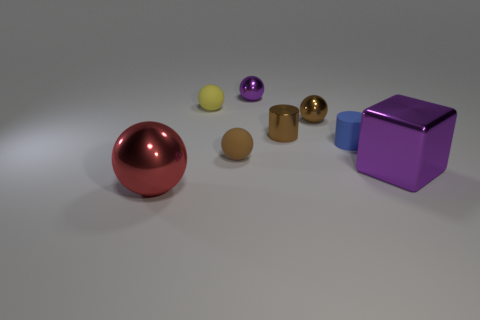There is a rubber object in front of the tiny blue cylinder in front of the tiny matte thing that is on the left side of the brown matte object; what is its color?
Ensure brevity in your answer.  Brown. Are there any other things that have the same shape as the large red metal thing?
Offer a terse response. Yes. Is the number of big metal balls greater than the number of metal objects?
Provide a succinct answer. No. What number of big objects are both left of the tiny purple shiny ball and on the right side of the small blue cylinder?
Offer a very short reply. 0. How many large purple shiny objects are right of the big object left of the brown matte sphere?
Your response must be concise. 1. There is a purple thing behind the metallic block; is it the same size as the purple thing that is right of the purple metallic sphere?
Keep it short and to the point. No. What number of blue matte cylinders are there?
Keep it short and to the point. 1. How many purple spheres have the same material as the big purple object?
Your answer should be compact. 1. Is the number of tiny rubber cylinders behind the yellow ball the same as the number of small metallic balls?
Provide a succinct answer. No. There is a object that is the same color as the block; what material is it?
Offer a very short reply. Metal. 